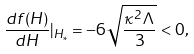<formula> <loc_0><loc_0><loc_500><loc_500>\frac { d f ( H ) } { d H } | _ { H _ { * } } = - 6 \sqrt { \frac { \kappa ^ { 2 } \Lambda } { 3 } } < 0 ,</formula> 